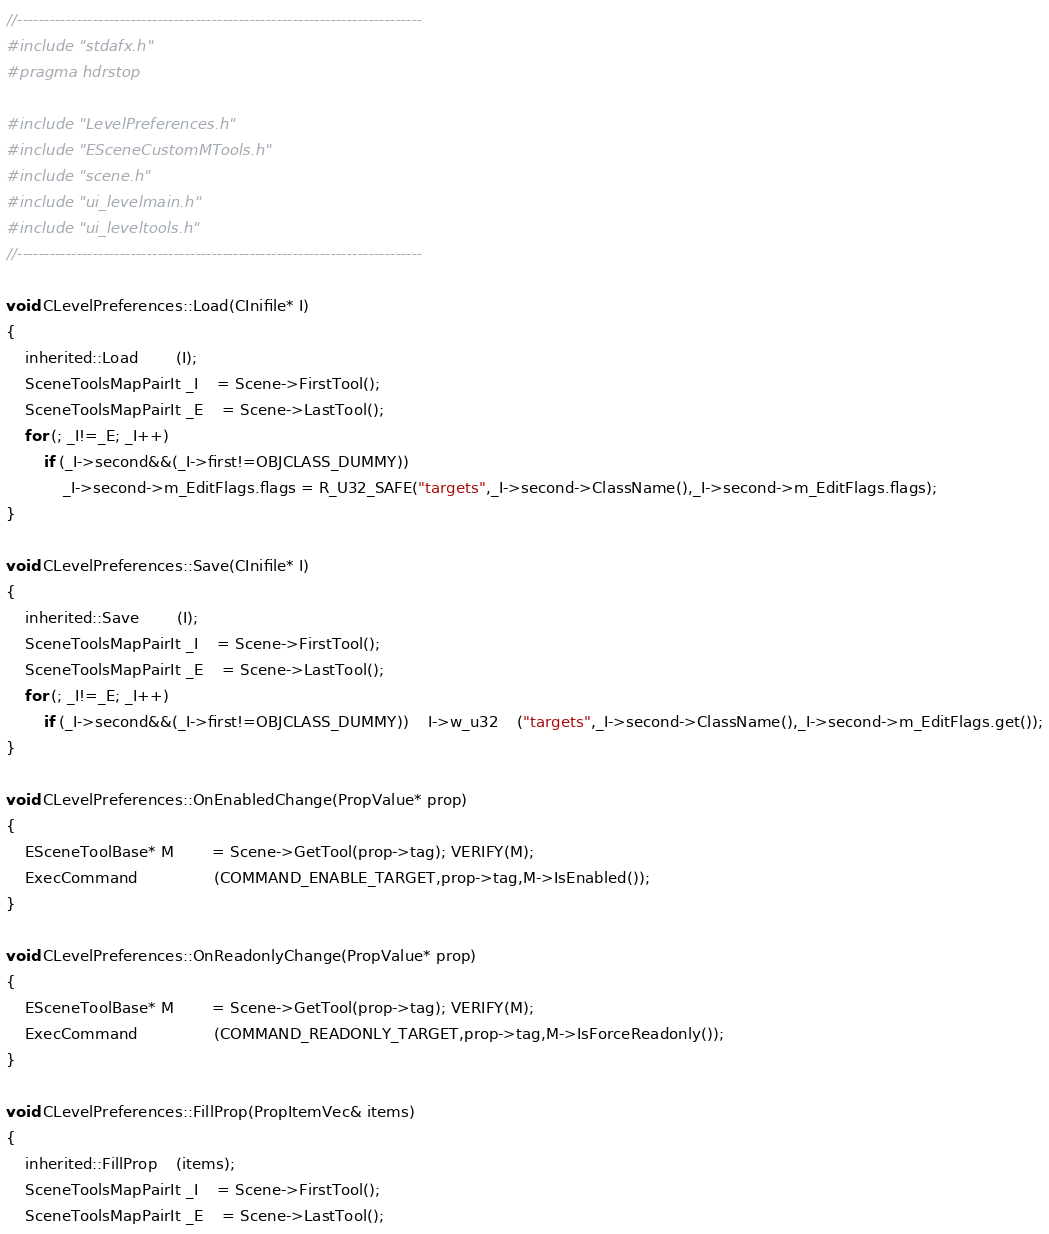Convert code to text. <code><loc_0><loc_0><loc_500><loc_500><_C++_>//---------------------------------------------------------------------------
#include "stdafx.h"
#pragma hdrstop

#include "LevelPreferences.h"
#include "ESceneCustomMTools.h"
#include "scene.h"
#include "ui_levelmain.h"
#include "ui_leveltools.h"
//---------------------------------------------------------------------------

void CLevelPreferences::Load(CInifile* I)
{
	inherited::Load		(I);                         
    SceneToolsMapPairIt _I 	= Scene->FirstTool();
    SceneToolsMapPairIt _E 	= Scene->LastTool();
    for (; _I!=_E; _I++)
        if (_I->second&&(_I->first!=OBJCLASS_DUMMY))
        	_I->second->m_EditFlags.flags = R_U32_SAFE("targets",_I->second->ClassName(),_I->second->m_EditFlags.flags);
}

void CLevelPreferences::Save(CInifile* I)
{
	inherited::Save		(I);
    SceneToolsMapPairIt _I 	= Scene->FirstTool();
    SceneToolsMapPairIt _E 	= Scene->LastTool();
    for (; _I!=_E; _I++)
        if (_I->second&&(_I->first!=OBJCLASS_DUMMY))	I->w_u32	("targets",_I->second->ClassName(),_I->second->m_EditFlags.get());
}

void CLevelPreferences::OnEnabledChange(PropValue* prop)
{
	ESceneToolBase* M		= Scene->GetTool(prop->tag); VERIFY(M);
	ExecCommand				(COMMAND_ENABLE_TARGET,prop->tag,M->IsEnabled());
}

void CLevelPreferences::OnReadonlyChange(PropValue* prop)
{
	ESceneToolBase* M		= Scene->GetTool(prop->tag); VERIFY(M);
	ExecCommand				(COMMAND_READONLY_TARGET,prop->tag,M->IsForceReadonly());
}

void CLevelPreferences::FillProp(PropItemVec& items)
{
	inherited::FillProp	(items);
    SceneToolsMapPairIt _I 	= Scene->FirstTool();
    SceneToolsMapPairIt _E 	= Scene->LastTool();</code> 